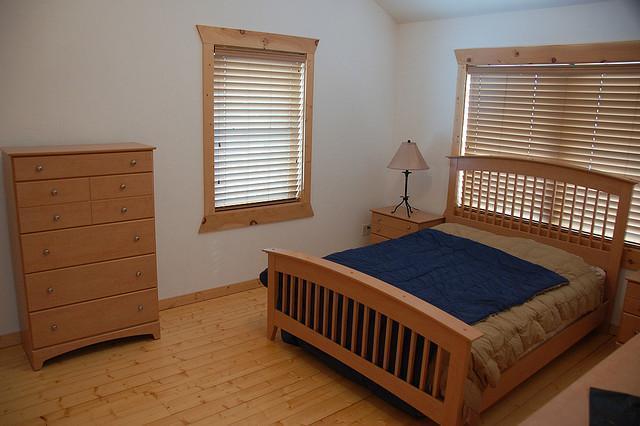How many windows are there?
Give a very brief answer. 2. How many people are riding this elephant?
Give a very brief answer. 0. 